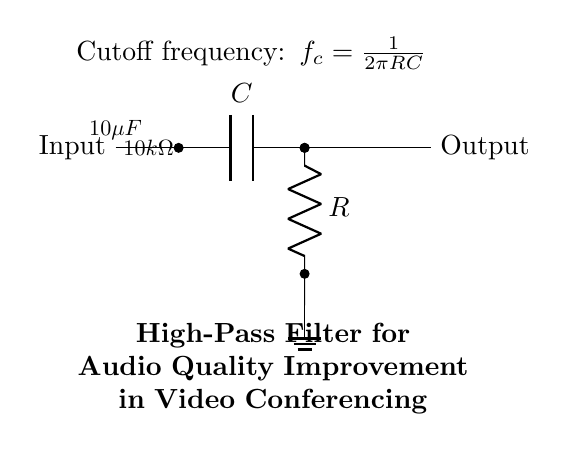What components are used in this circuit? The diagram shows a capacitor and a resistor. The labels indicate that the capacitor is denoted as 'C' and the resistor as 'R'.
Answer: capacitor and resistor What is the capacitor value in this circuit? The value of the capacitor is specified in the diagram as ten microfarads.
Answer: ten microfarads What is the resistor value in this circuit? The resistor value is indicated in the diagram as ten kiloohms.
Answer: ten kiloohms What type of filter is represented in this circuit? The circuit is identified as a high-pass filter, which is noted in the title of the diagram.
Answer: high-pass filter What is the purpose of this circuit? The circuit is designed to improve audio quality, particularly for video conferencing systems, as mentioned in the title.
Answer: improve audio quality What is the cutoff frequency formula for this high-pass filter? The cutoff frequency formula is provided in the diagram as one divided by two pi times the resistance times the capacitance.
Answer: one divided by two pi times resistance times capacitance How does this circuit affect low-frequency signals? This high-pass filter allows signals with frequencies above the cutoff frequency to pass through while attenuating signals with frequencies below that level.
Answer: attenuates low-frequency signals 